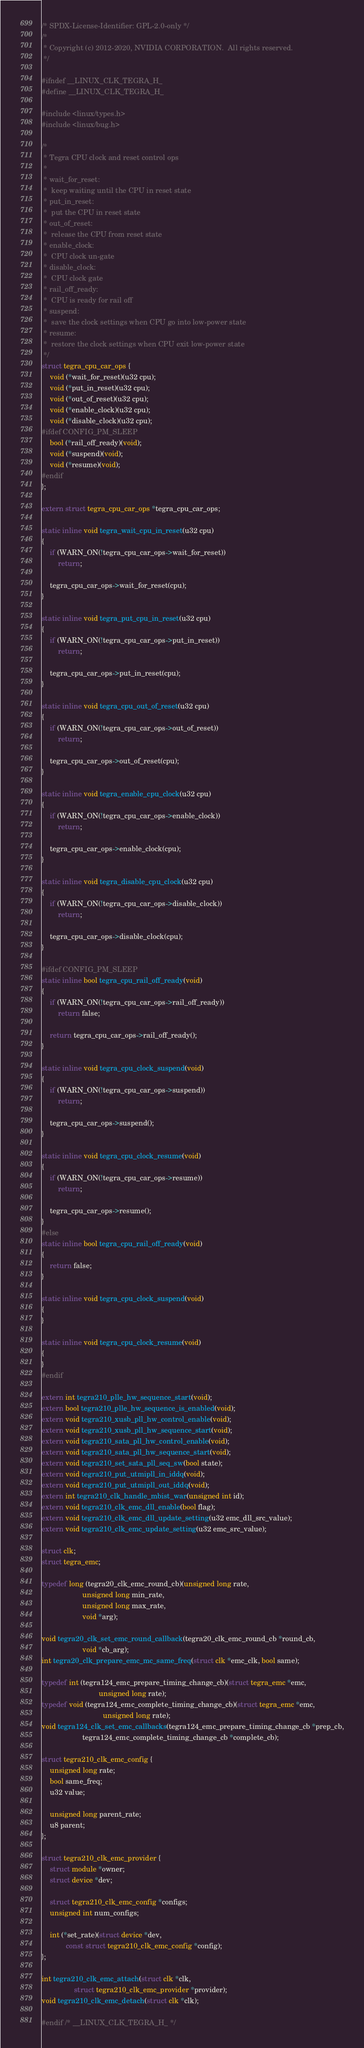Convert code to text. <code><loc_0><loc_0><loc_500><loc_500><_C_>/* SPDX-License-Identifier: GPL-2.0-only */
/*
 * Copyright (c) 2012-2020, NVIDIA CORPORATION.  All rights reserved.
 */

#ifndef __LINUX_CLK_TEGRA_H_
#define __LINUX_CLK_TEGRA_H_

#include <linux/types.h>
#include <linux/bug.h>

/*
 * Tegra CPU clock and reset control ops
 *
 * wait_for_reset:
 *	keep waiting until the CPU in reset state
 * put_in_reset:
 *	put the CPU in reset state
 * out_of_reset:
 *	release the CPU from reset state
 * enable_clock:
 *	CPU clock un-gate
 * disable_clock:
 *	CPU clock gate
 * rail_off_ready:
 *	CPU is ready for rail off
 * suspend:
 *	save the clock settings when CPU go into low-power state
 * resume:
 *	restore the clock settings when CPU exit low-power state
 */
struct tegra_cpu_car_ops {
	void (*wait_for_reset)(u32 cpu);
	void (*put_in_reset)(u32 cpu);
	void (*out_of_reset)(u32 cpu);
	void (*enable_clock)(u32 cpu);
	void (*disable_clock)(u32 cpu);
#ifdef CONFIG_PM_SLEEP
	bool (*rail_off_ready)(void);
	void (*suspend)(void);
	void (*resume)(void);
#endif
};

extern struct tegra_cpu_car_ops *tegra_cpu_car_ops;

static inline void tegra_wait_cpu_in_reset(u32 cpu)
{
	if (WARN_ON(!tegra_cpu_car_ops->wait_for_reset))
		return;

	tegra_cpu_car_ops->wait_for_reset(cpu);
}

static inline void tegra_put_cpu_in_reset(u32 cpu)
{
	if (WARN_ON(!tegra_cpu_car_ops->put_in_reset))
		return;

	tegra_cpu_car_ops->put_in_reset(cpu);
}

static inline void tegra_cpu_out_of_reset(u32 cpu)
{
	if (WARN_ON(!tegra_cpu_car_ops->out_of_reset))
		return;

	tegra_cpu_car_ops->out_of_reset(cpu);
}

static inline void tegra_enable_cpu_clock(u32 cpu)
{
	if (WARN_ON(!tegra_cpu_car_ops->enable_clock))
		return;

	tegra_cpu_car_ops->enable_clock(cpu);
}

static inline void tegra_disable_cpu_clock(u32 cpu)
{
	if (WARN_ON(!tegra_cpu_car_ops->disable_clock))
		return;

	tegra_cpu_car_ops->disable_clock(cpu);
}

#ifdef CONFIG_PM_SLEEP
static inline bool tegra_cpu_rail_off_ready(void)
{
	if (WARN_ON(!tegra_cpu_car_ops->rail_off_ready))
		return false;

	return tegra_cpu_car_ops->rail_off_ready();
}

static inline void tegra_cpu_clock_suspend(void)
{
	if (WARN_ON(!tegra_cpu_car_ops->suspend))
		return;

	tegra_cpu_car_ops->suspend();
}

static inline void tegra_cpu_clock_resume(void)
{
	if (WARN_ON(!tegra_cpu_car_ops->resume))
		return;

	tegra_cpu_car_ops->resume();
}
#else
static inline bool tegra_cpu_rail_off_ready(void)
{
	return false;
}

static inline void tegra_cpu_clock_suspend(void)
{
}

static inline void tegra_cpu_clock_resume(void)
{
}
#endif

extern int tegra210_plle_hw_sequence_start(void);
extern bool tegra210_plle_hw_sequence_is_enabled(void);
extern void tegra210_xusb_pll_hw_control_enable(void);
extern void tegra210_xusb_pll_hw_sequence_start(void);
extern void tegra210_sata_pll_hw_control_enable(void);
extern void tegra210_sata_pll_hw_sequence_start(void);
extern void tegra210_set_sata_pll_seq_sw(bool state);
extern void tegra210_put_utmipll_in_iddq(void);
extern void tegra210_put_utmipll_out_iddq(void);
extern int tegra210_clk_handle_mbist_war(unsigned int id);
extern void tegra210_clk_emc_dll_enable(bool flag);
extern void tegra210_clk_emc_dll_update_setting(u32 emc_dll_src_value);
extern void tegra210_clk_emc_update_setting(u32 emc_src_value);

struct clk;
struct tegra_emc;

typedef long (tegra20_clk_emc_round_cb)(unsigned long rate,
					unsigned long min_rate,
					unsigned long max_rate,
					void *arg);

void tegra20_clk_set_emc_round_callback(tegra20_clk_emc_round_cb *round_cb,
					void *cb_arg);
int tegra20_clk_prepare_emc_mc_same_freq(struct clk *emc_clk, bool same);

typedef int (tegra124_emc_prepare_timing_change_cb)(struct tegra_emc *emc,
						    unsigned long rate);
typedef void (tegra124_emc_complete_timing_change_cb)(struct tegra_emc *emc,
						      unsigned long rate);
void tegra124_clk_set_emc_callbacks(tegra124_emc_prepare_timing_change_cb *prep_cb,
				    tegra124_emc_complete_timing_change_cb *complete_cb);

struct tegra210_clk_emc_config {
	unsigned long rate;
	bool same_freq;
	u32 value;

	unsigned long parent_rate;
	u8 parent;
};

struct tegra210_clk_emc_provider {
	struct module *owner;
	struct device *dev;

	struct tegra210_clk_emc_config *configs;
	unsigned int num_configs;

	int (*set_rate)(struct device *dev,
			const struct tegra210_clk_emc_config *config);
};

int tegra210_clk_emc_attach(struct clk *clk,
			    struct tegra210_clk_emc_provider *provider);
void tegra210_clk_emc_detach(struct clk *clk);

#endif /* __LINUX_CLK_TEGRA_H_ */
</code> 